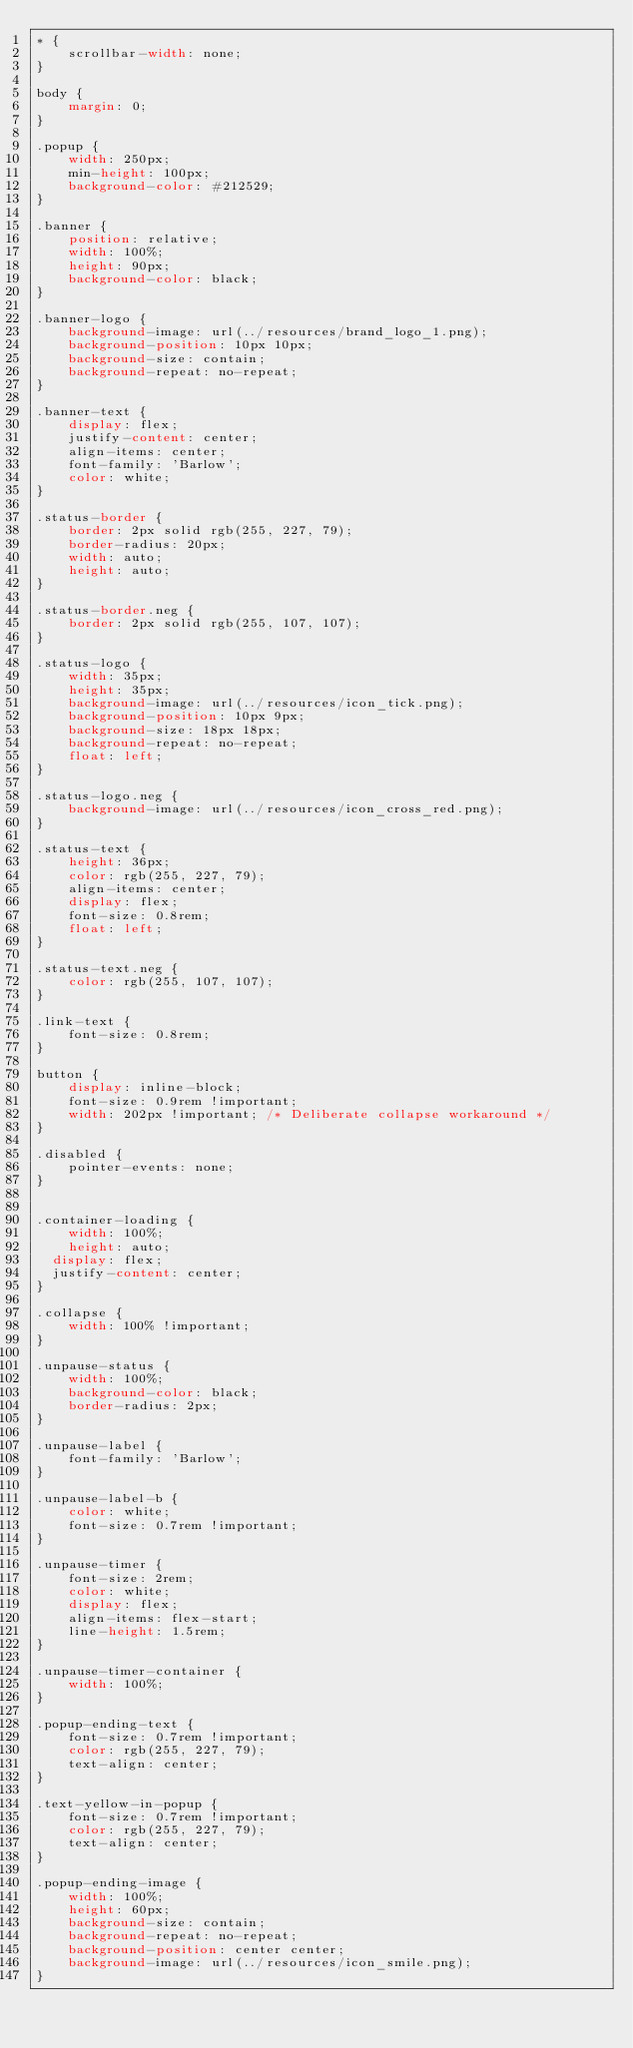Convert code to text. <code><loc_0><loc_0><loc_500><loc_500><_CSS_>* {
	scrollbar-width: none;
}

body {
	margin: 0;
}

.popup {
	width: 250px;
	min-height: 100px;
	background-color: #212529;
}

.banner {
	position: relative;
	width: 100%;
	height: 90px;
	background-color: black;
}

.banner-logo {
	background-image: url(../resources/brand_logo_1.png);
    background-position: 10px 10px;
    background-size: contain;
    background-repeat: no-repeat;
}

.banner-text {
	display: flex;
    justify-content: center;
    align-items: center;
    font-family: 'Barlow';
    color: white;
}

.status-border {
	border: 2px solid rgb(255, 227, 79);
    border-radius: 20px;
    width: auto;
    height: auto;
}

.status-border.neg {
	border: 2px solid rgb(255, 107, 107);
}

.status-logo {
	width: 35px;
	height: 35px;
	background-image: url(../resources/icon_tick.png);
	background-position: 10px 9px;
    background-size: 18px 18px;
    background-repeat: no-repeat;
    float: left;
}

.status-logo.neg {
	background-image: url(../resources/icon_cross_red.png);
}

.status-text {
	height: 36px;
    color: rgb(255, 227, 79);
    align-items: center;
    display: flex;
    font-size: 0.8rem;
    float: left;
}

.status-text.neg {
    color: rgb(255, 107, 107);
}

.link-text {
	font-size: 0.8rem;
}

button {
	display: inline-block;
	font-size: 0.9rem !important;
	width: 202px !important; /* Deliberate collapse workaround */
}

.disabled {
	pointer-events: none;
}


.container-loading {
	width: 100%;
	height: auto;
  display: flex;
  justify-content: center;
}

.collapse {
	width: 100% !important;
}

.unpause-status {
	width: 100%;
    background-color: black;
    border-radius: 2px;
}

.unpause-label {
	font-family: 'Barlow';
}

.unpause-label-b {
	color: white;
	font-size: 0.7rem !important;
}

.unpause-timer {
	font-size: 2rem;
    color: white;
    display: flex;
    align-items: flex-start;
    line-height: 1.5rem;
}

.unpause-timer-container {
	width: 100%;
}

.popup-ending-text {
	font-size: 0.7rem !important;
    color: rgb(255, 227, 79);
    text-align: center;
}

.text-yellow-in-popup {
	font-size: 0.7rem !important;
    color: rgb(255, 227, 79);
    text-align: center;
}

.popup-ending-image {
	width: 100%;
	height: 60px;
	background-size: contain;
    background-repeat: no-repeat;
    background-position: center center;
	background-image: url(../resources/icon_smile.png);
}



</code> 